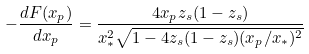Convert formula to latex. <formula><loc_0><loc_0><loc_500><loc_500>- \frac { d F ( x _ { p } ) } { d x _ { p } } = \frac { 4 x _ { p } z _ { s } ( 1 - z _ { s } ) } { x _ { * } ^ { 2 } \sqrt { 1 - 4 z _ { s } ( 1 - z _ { s } ) ( x _ { p } / x _ { * } ) ^ { 2 } } }</formula> 